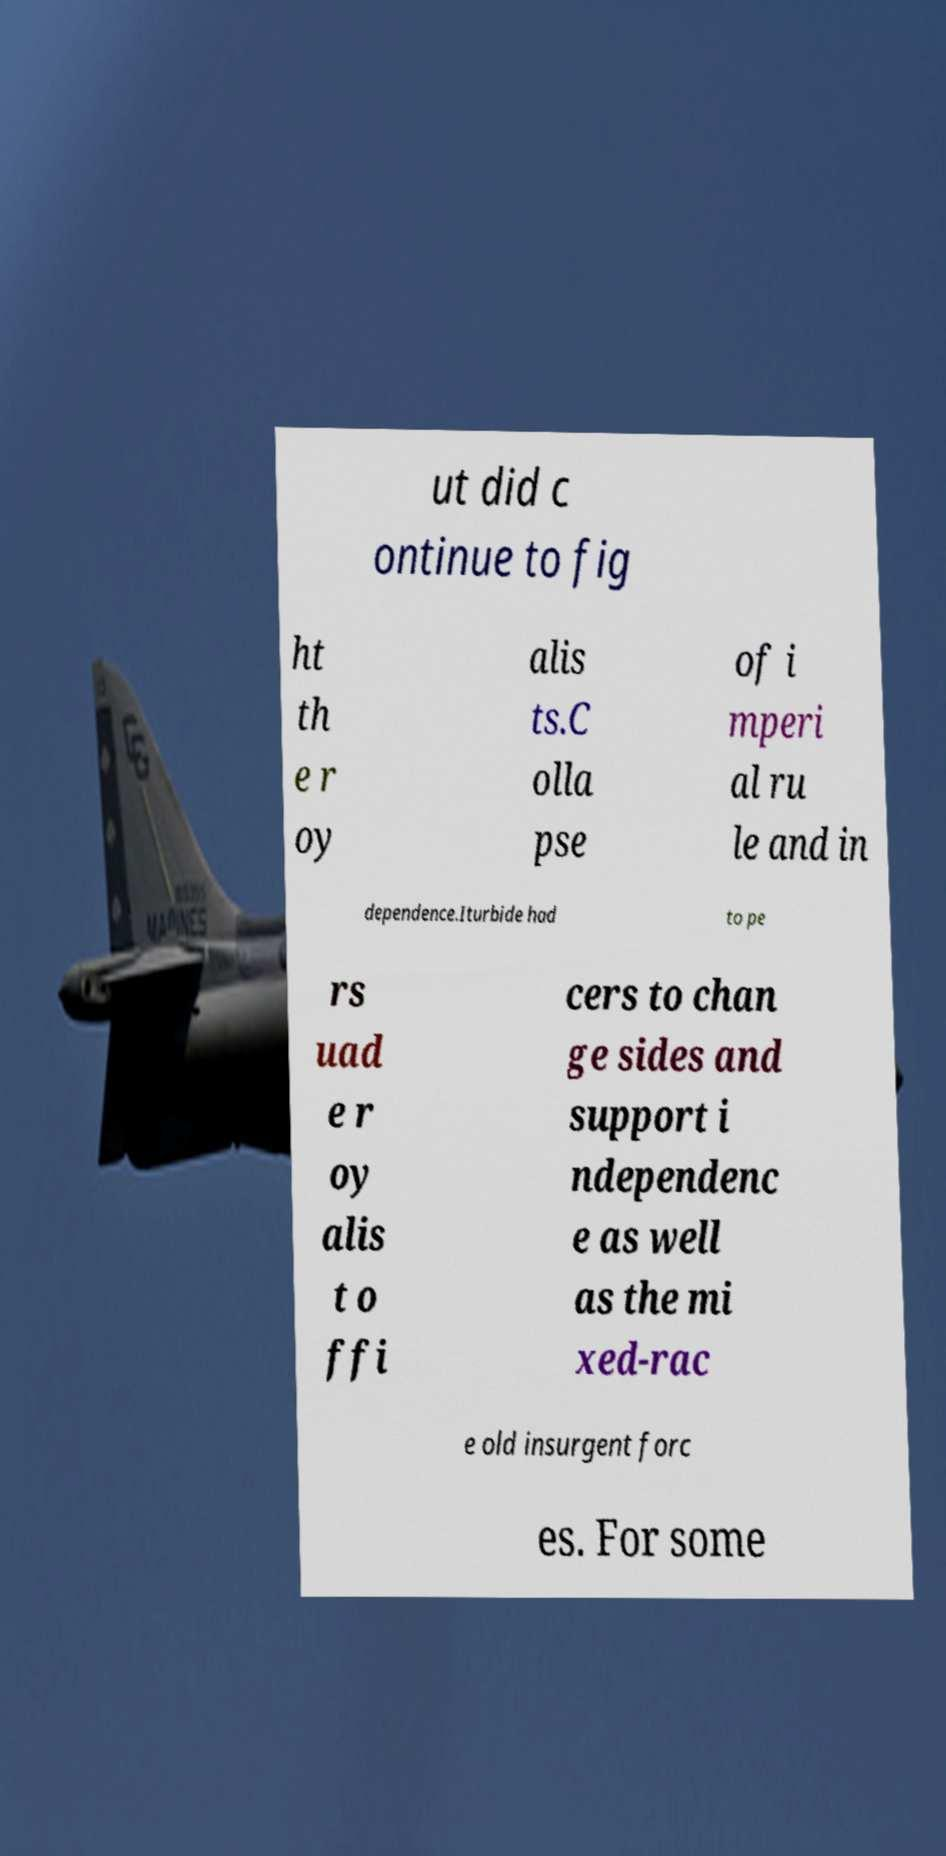Please read and relay the text visible in this image. What does it say? ut did c ontinue to fig ht th e r oy alis ts.C olla pse of i mperi al ru le and in dependence.Iturbide had to pe rs uad e r oy alis t o ffi cers to chan ge sides and support i ndependenc e as well as the mi xed-rac e old insurgent forc es. For some 